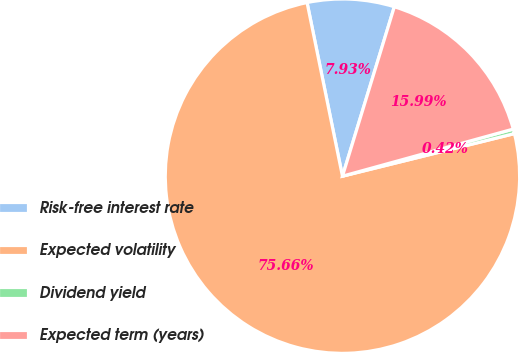Convert chart. <chart><loc_0><loc_0><loc_500><loc_500><pie_chart><fcel>Risk-free interest rate<fcel>Expected volatility<fcel>Dividend yield<fcel>Expected term (years)<nl><fcel>7.93%<fcel>75.66%<fcel>0.42%<fcel>15.99%<nl></chart> 